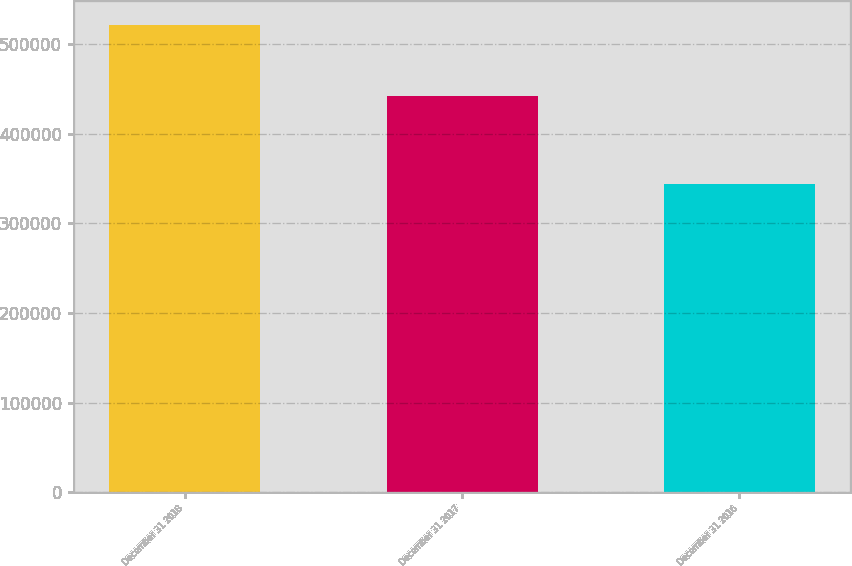Convert chart. <chart><loc_0><loc_0><loc_500><loc_500><bar_chart><fcel>December 31 2018<fcel>December 31 2017<fcel>December 31 2016<nl><fcel>521579<fcel>442364<fcel>343515<nl></chart> 